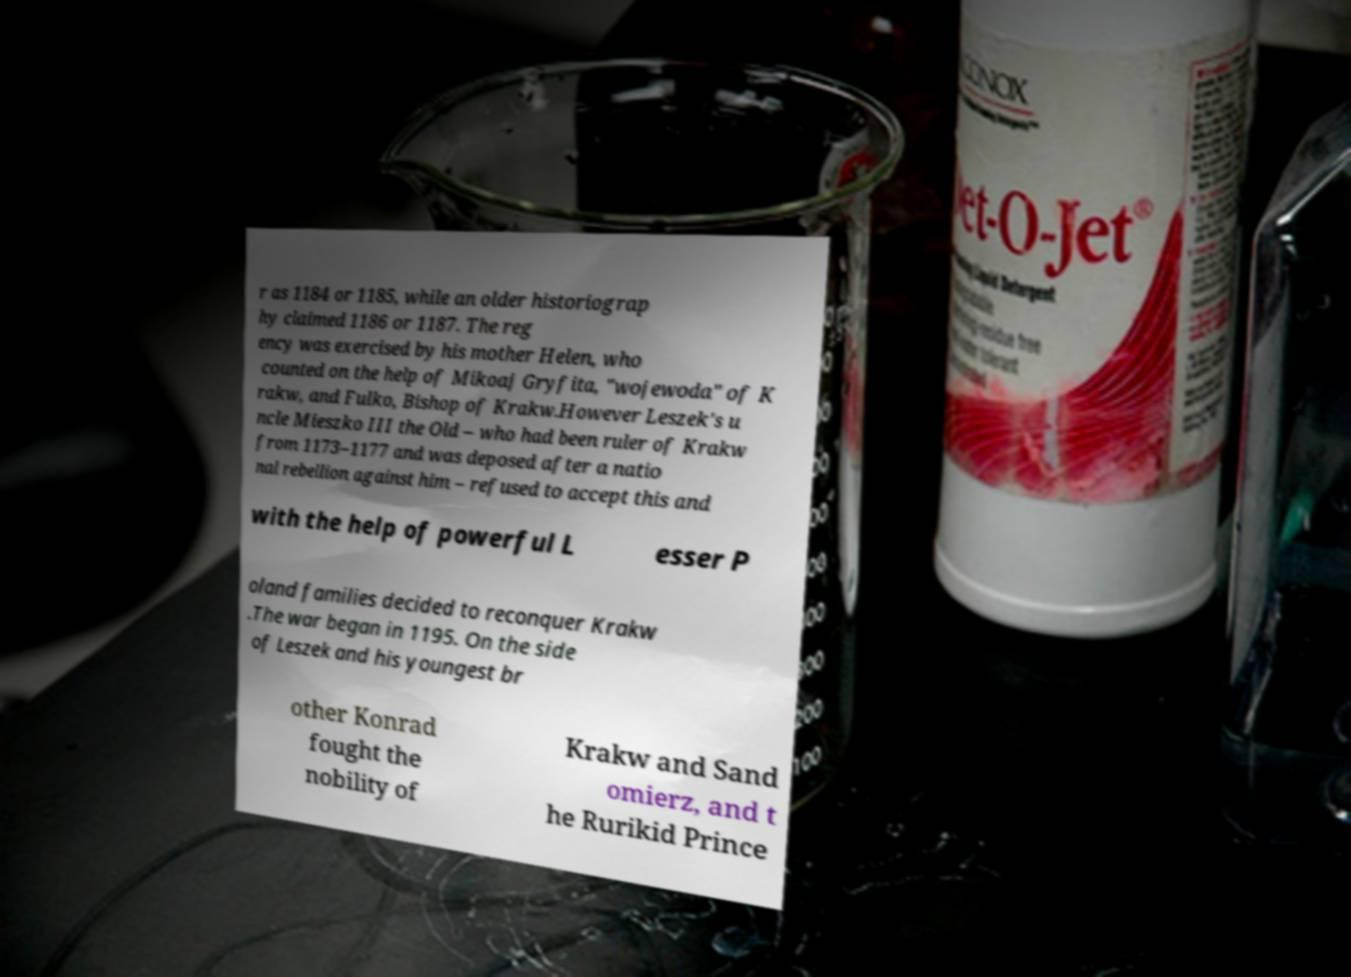What messages or text are displayed in this image? I need them in a readable, typed format. r as 1184 or 1185, while an older historiograp hy claimed 1186 or 1187. The reg ency was exercised by his mother Helen, who counted on the help of Mikoaj Gryfita, "wojewoda" of K rakw, and Fulko, Bishop of Krakw.However Leszek's u ncle Mieszko III the Old – who had been ruler of Krakw from 1173–1177 and was deposed after a natio nal rebellion against him – refused to accept this and with the help of powerful L esser P oland families decided to reconquer Krakw .The war began in 1195. On the side of Leszek and his youngest br other Konrad fought the nobility of Krakw and Sand omierz, and t he Rurikid Prince 